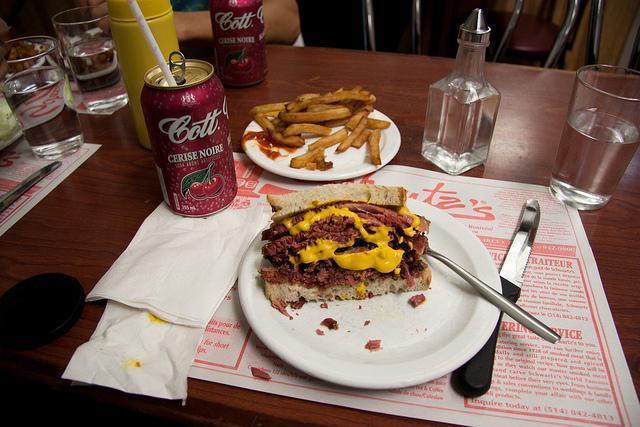How many chairs are in the photo?
Give a very brief answer. 2. How many bottles can you see?
Give a very brief answer. 2. How many cups can be seen?
Give a very brief answer. 3. 